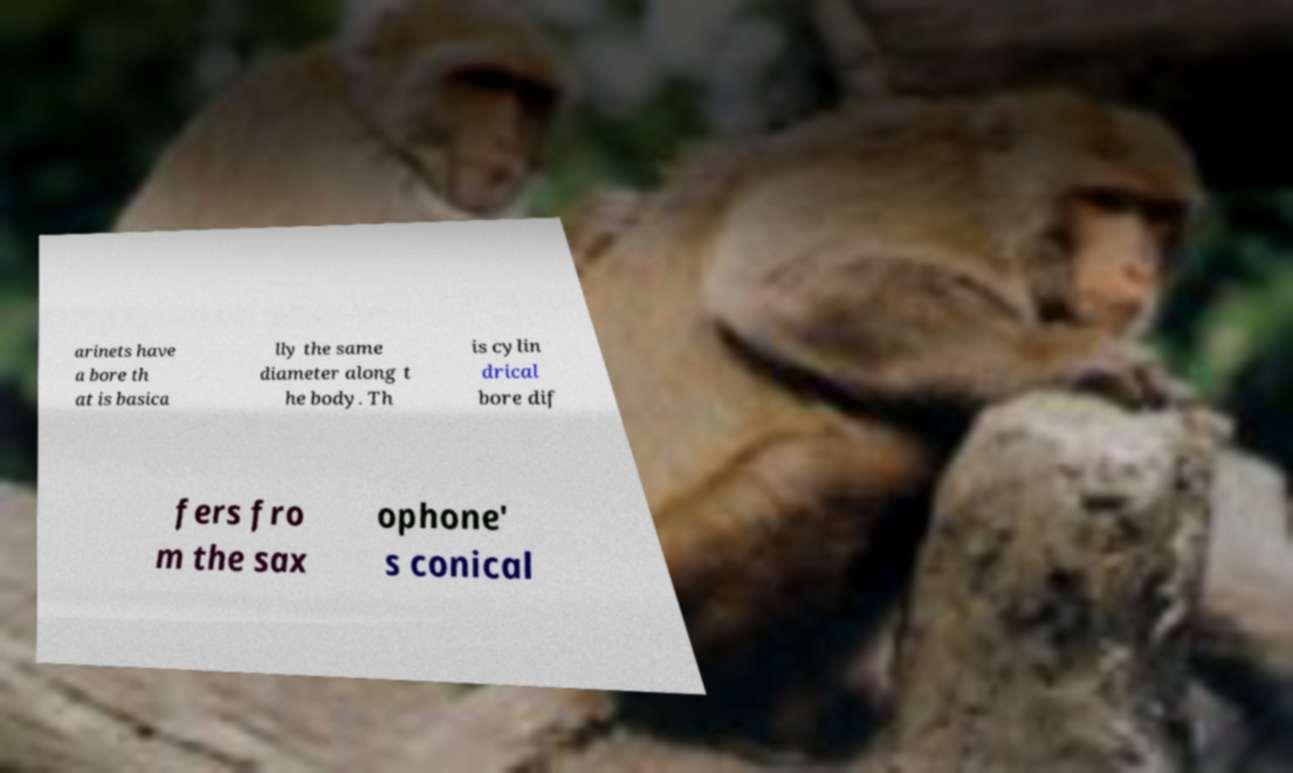I need the written content from this picture converted into text. Can you do that? arinets have a bore th at is basica lly the same diameter along t he body. Th is cylin drical bore dif fers fro m the sax ophone' s conical 